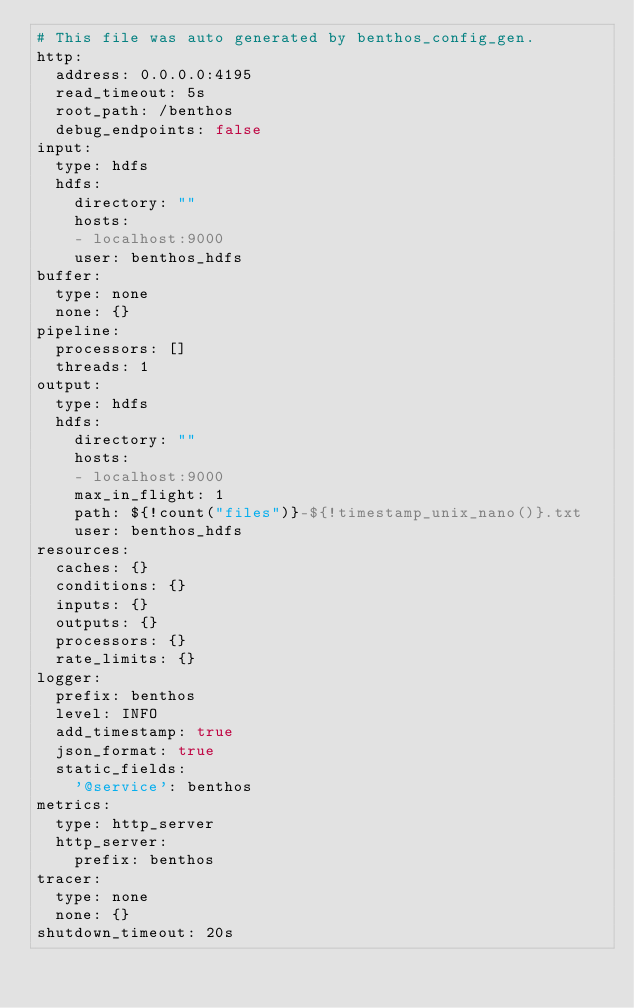<code> <loc_0><loc_0><loc_500><loc_500><_YAML_># This file was auto generated by benthos_config_gen.
http:
  address: 0.0.0.0:4195
  read_timeout: 5s
  root_path: /benthos
  debug_endpoints: false
input:
  type: hdfs
  hdfs:
    directory: ""
    hosts:
    - localhost:9000
    user: benthos_hdfs
buffer:
  type: none
  none: {}
pipeline:
  processors: []
  threads: 1
output:
  type: hdfs
  hdfs:
    directory: ""
    hosts:
    - localhost:9000
    max_in_flight: 1
    path: ${!count("files")}-${!timestamp_unix_nano()}.txt
    user: benthos_hdfs
resources:
  caches: {}
  conditions: {}
  inputs: {}
  outputs: {}
  processors: {}
  rate_limits: {}
logger:
  prefix: benthos
  level: INFO
  add_timestamp: true
  json_format: true
  static_fields:
    '@service': benthos
metrics:
  type: http_server
  http_server:
    prefix: benthos
tracer:
  type: none
  none: {}
shutdown_timeout: 20s
</code> 